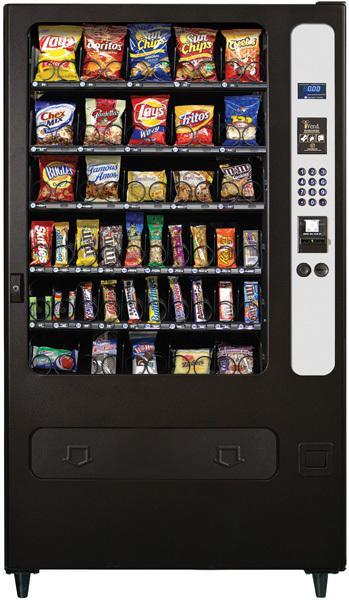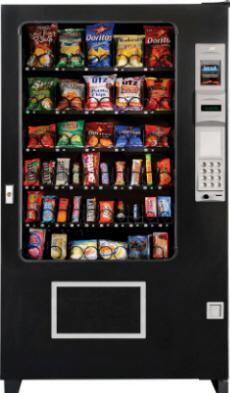The first image is the image on the left, the second image is the image on the right. Evaluate the accuracy of this statement regarding the images: "The dispensing port of the vending machine in the image on the right is outlined in gray.". Is it true? Answer yes or no. Yes. 